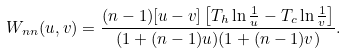Convert formula to latex. <formula><loc_0><loc_0><loc_500><loc_500>W _ { n n } ( u , v ) = \frac { ( n - 1 ) [ u - v ] \left [ T _ { h } \ln \frac { 1 } { u } - T _ { c } \ln \frac { 1 } { v } \right ] } { ( 1 + ( n - 1 ) u ) ( 1 + ( n - 1 ) v ) } .</formula> 